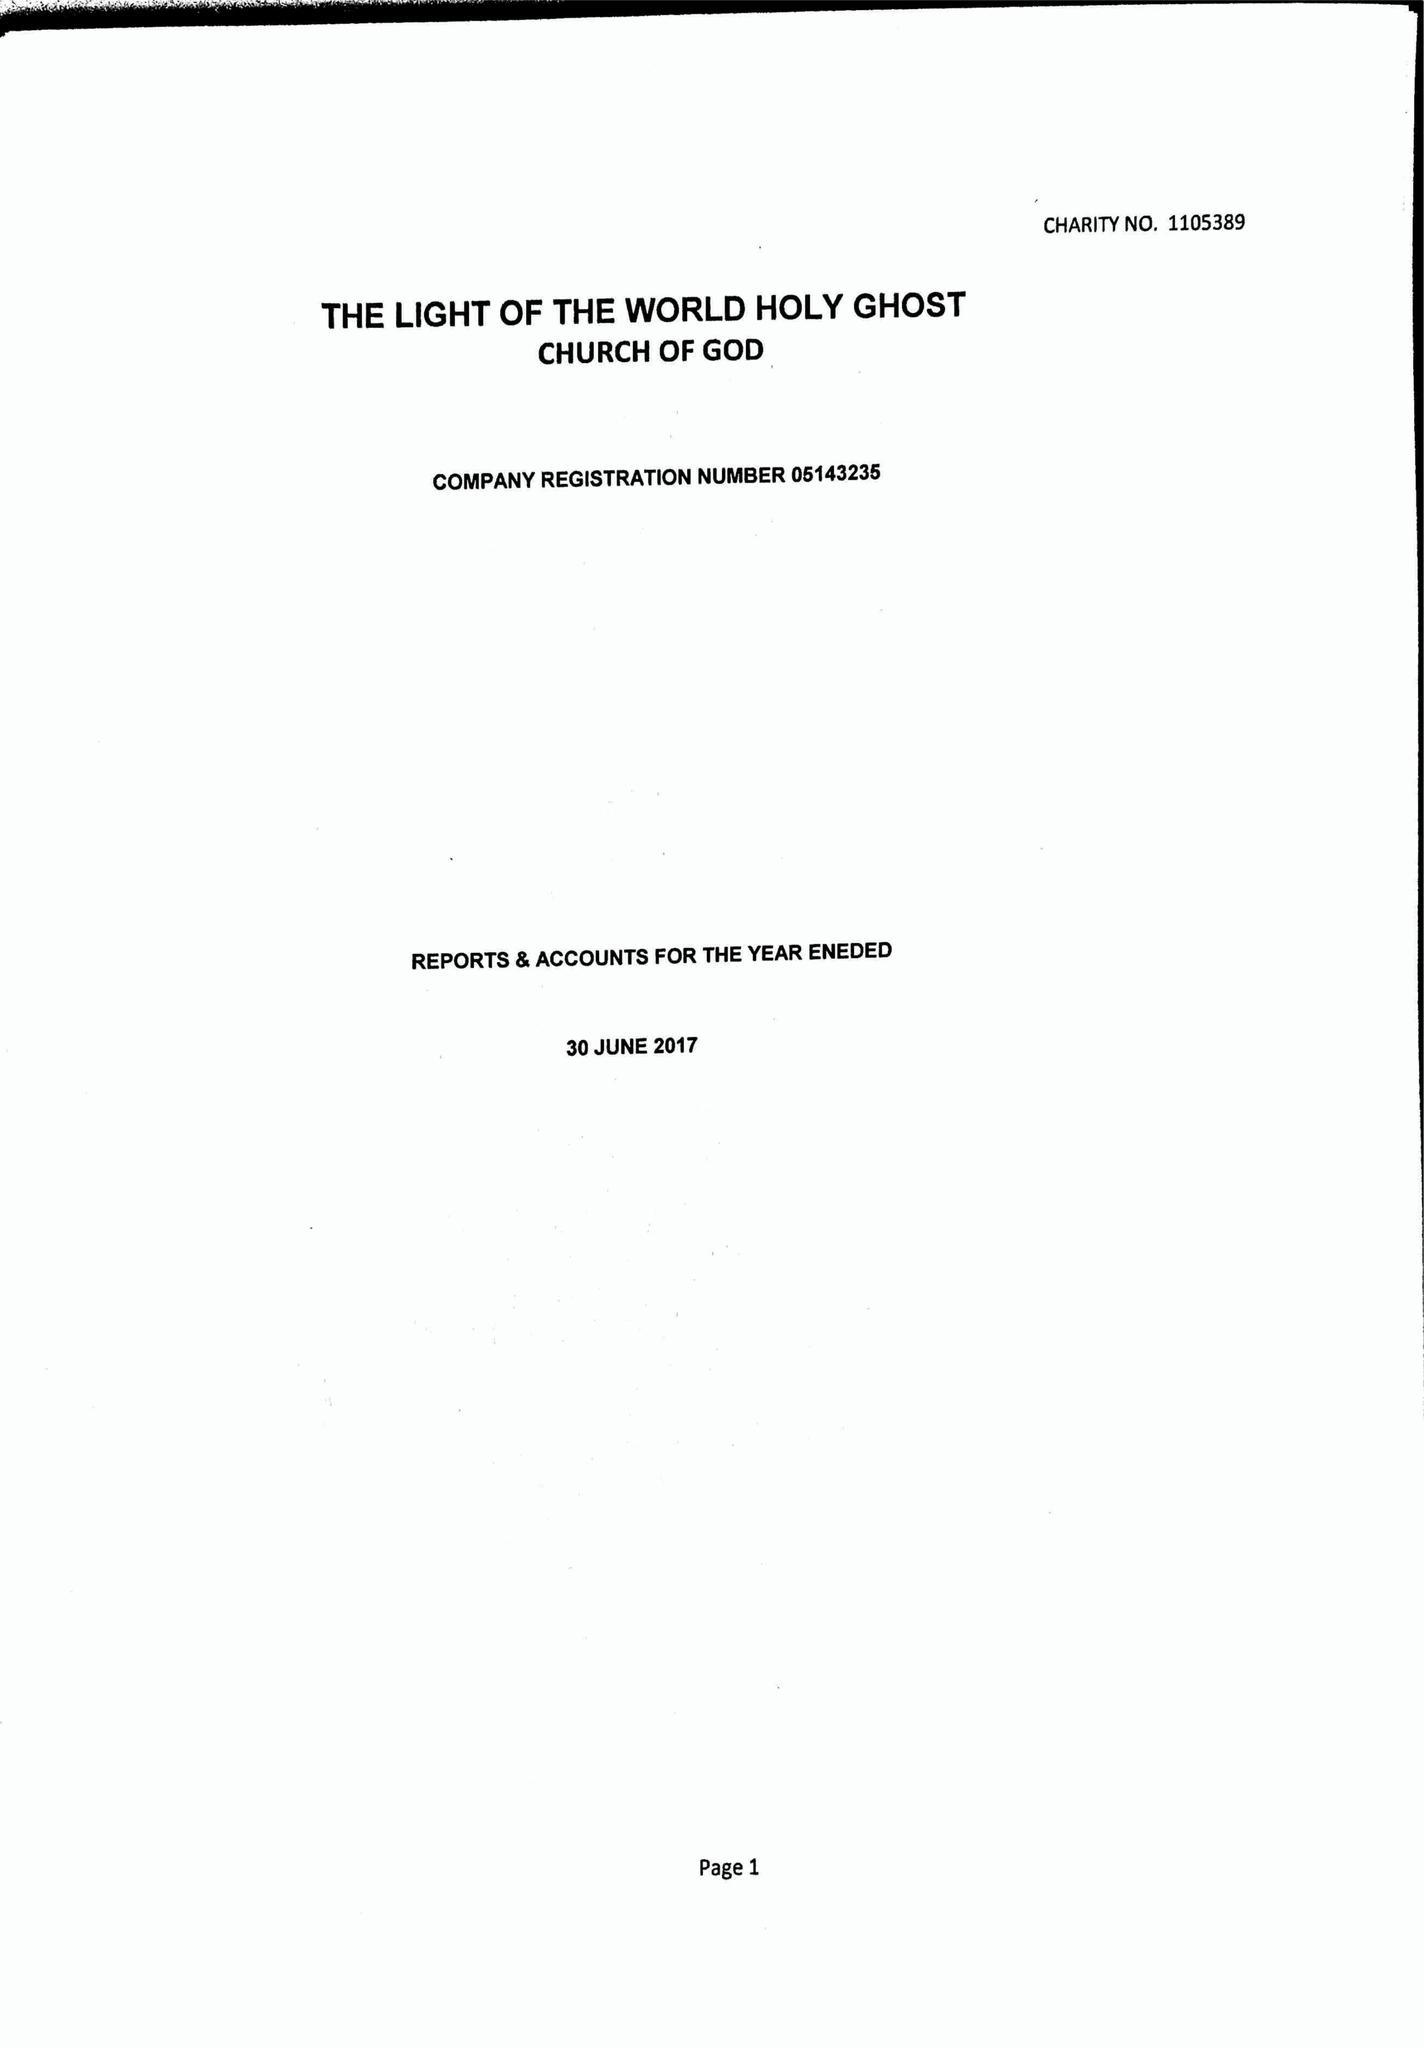What is the value for the address__post_town?
Answer the question using a single word or phrase. KENT 